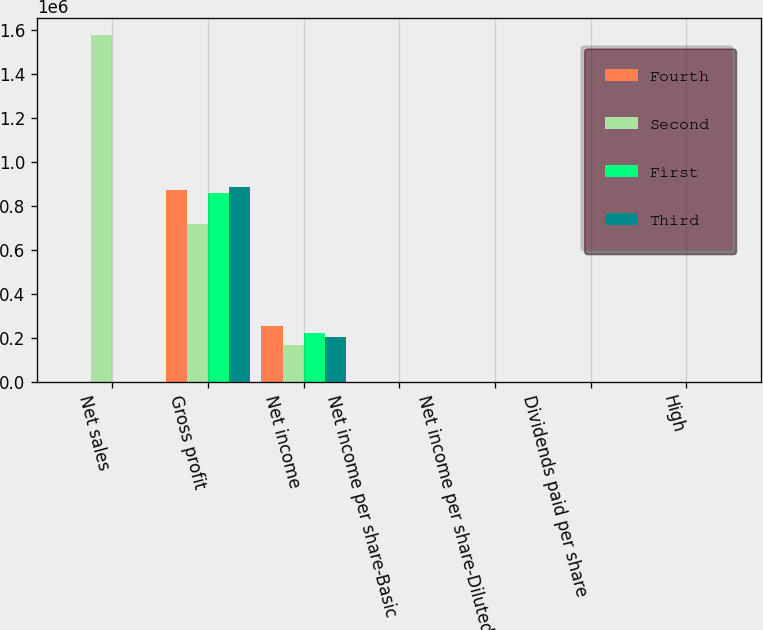<chart> <loc_0><loc_0><loc_500><loc_500><stacked_bar_chart><ecel><fcel>Net sales<fcel>Gross profit<fcel>Net income<fcel>Net income per share-Basic<fcel>Net income per share-Diluted<fcel>Dividends paid per share<fcel>High<nl><fcel>Fourth<fcel>1.11<fcel>871490<fcel>252495<fcel>1.16<fcel>1.03<fcel>0.48<fcel>108.07<nl><fcel>Second<fcel>1.57835e+06<fcel>717474<fcel>168168<fcel>0.78<fcel>0.7<fcel>0.48<fcel>104.11<nl><fcel>First<fcel>1.11<fcel>860137<fcel>223741<fcel>1.03<fcel>0.94<fcel>0.54<fcel>96.93<nl><fcel>Third<fcel>1.11<fcel>887065<fcel>202508<fcel>0.94<fcel>0.85<fcel>0.54<fcel>106.64<nl></chart> 